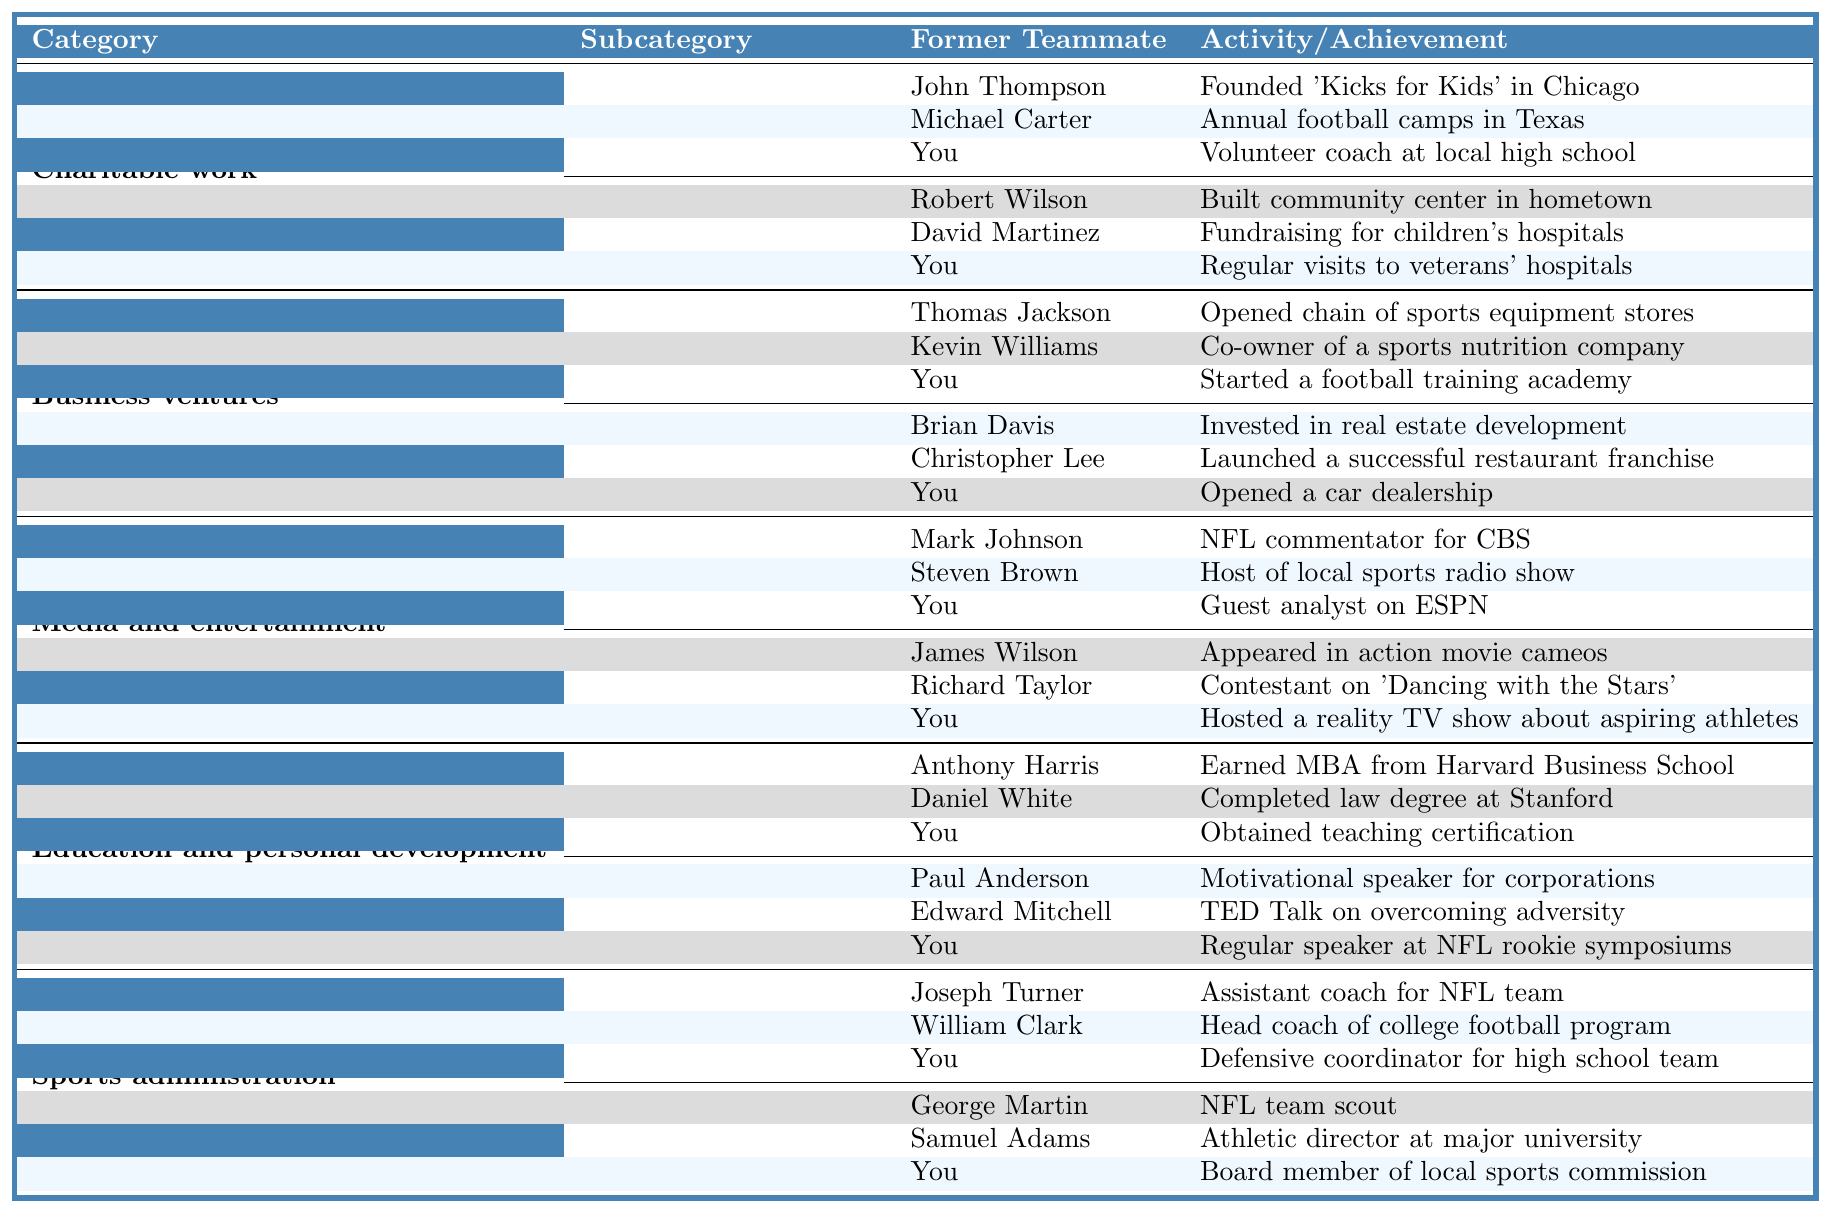What charitable work did Robert Wilson engage in? According to the table, Robert Wilson built a community center in his hometown, which is listed under the charitable work category and the community outreach subcategory.
Answer: Built community center in hometown Which former teammate has started a sports-related business venture? The table lists multiple former teammates in the business ventures category under sports-related subcategory. Thomas Jackson opened a chain of sports equipment stores, Kevin Williams co-owns a sports nutrition company, and you started a football training academy.
Answer: Thomas Jackson, Kevin Williams, and you Are there any former teammates who have worked in broadcasting? The table provides information under the media and entertainment category in the broadcasting subcategory listing Mark Johnson as an NFL commentator for CBS, Steven Brown as the host of a local sports radio show, and you as a guest analyst on ESPN. Therefore, there are former teammates who have worked in broadcasting.
Answer: Yes What is the total number of charitable work activities mentioned in the table? The table indicates that there are two subcategories under charitable work: youth football programs and community outreach. Each has three activities: a total of 3 + 3 = 6 charitable work activities.
Answer: 6 Who hosted a reality TV show about aspiring athletes? The table reveals that you hosted a reality TV show about aspiring athletes, which is listed under the media and entertainment category in the television and film subcategory.
Answer: You Which former teammate has an educational achievement related to formal education? The table lists Anthony Harris who earned an MBA from Harvard Business School, and Daniel White who completed a law degree at Stanford. You also obtained a teaching certification. Therefore, there are multiple former teammates with educational achievements in this category.
Answer: Anthony Harris, Daniel White, and you Who has the role of defensive coordinator for a high school team? The table specifies that you are the defensive coordinator for a high school team, found under the sports administration category in the coaching subcategory.
Answer: You In which area did Michael Carter contribute through charitable work? Michael Carter is mentioned in the table under the youth football programs subcategory where he holds annual football camps in Texas.
Answer: Annual football camps in Texas Which teammate transitioned to a role in sports management? The table states that you are a board member of the local sports commission, which falls under the sports administration category in the management subcategory.
Answer: You What are the main categories of activities for former teammates listed in the table? The table organizes the activities into five main categories: Charitable work, Business ventures, Media and entertainment, Education and personal development, and Sports administration.
Answer: Charitable work, Business ventures, Media and entertainment, Education and personal development, Sports administration 